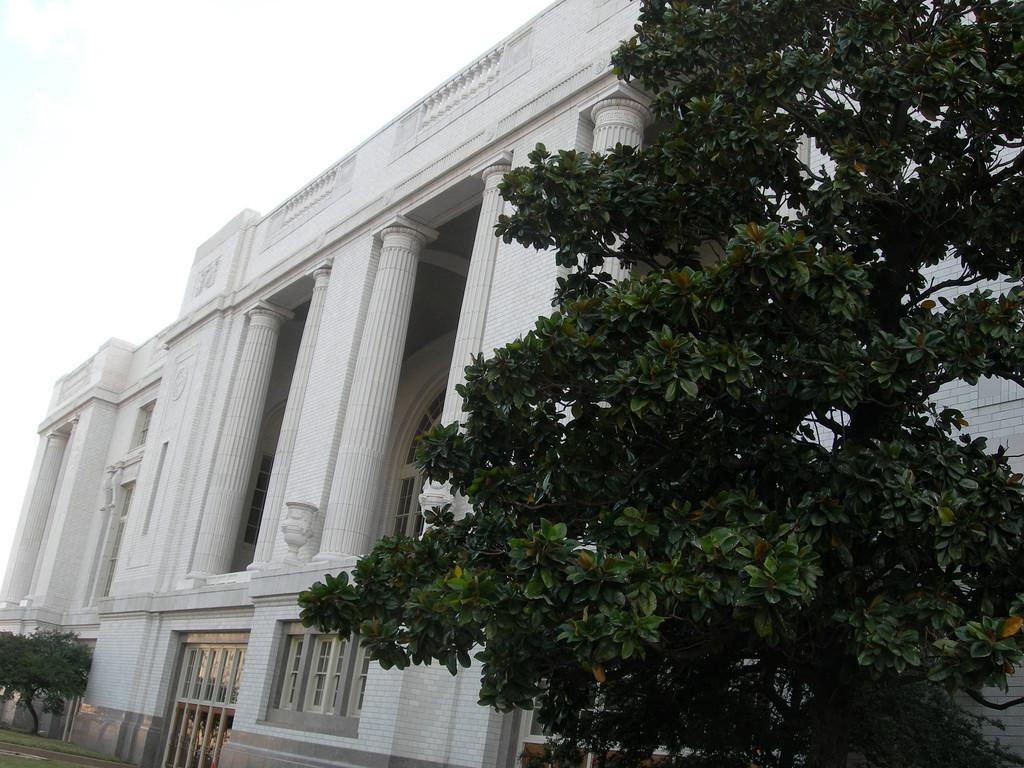What is located on the right side of the image? There is a tree on the right side of the image. Are there any other trees visible in the image? Yes, there is a big tree near the first tree. What can be seen in the background of the image? The background of the image is the sky. What type of oil can be seen dripping from the tree in the image? There is no oil present in the image; it features trees and a sky background. 